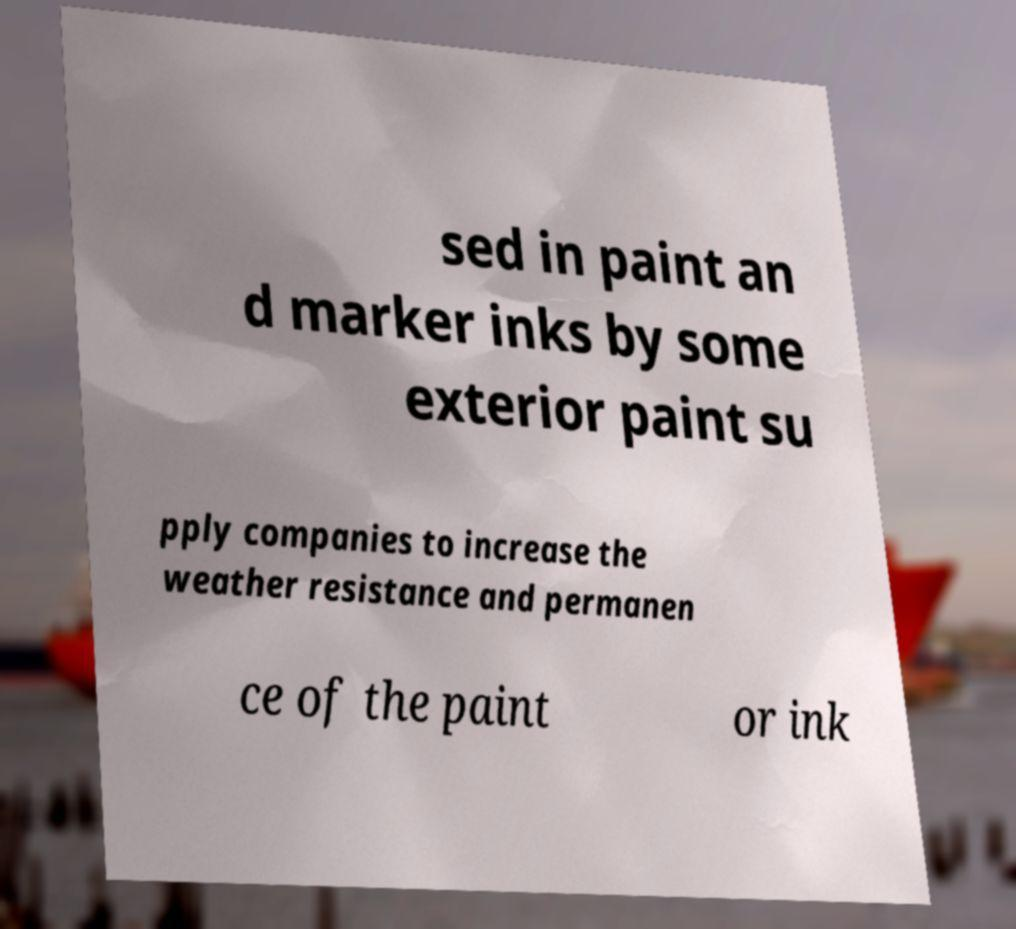I need the written content from this picture converted into text. Can you do that? sed in paint an d marker inks by some exterior paint su pply companies to increase the weather resistance and permanen ce of the paint or ink 